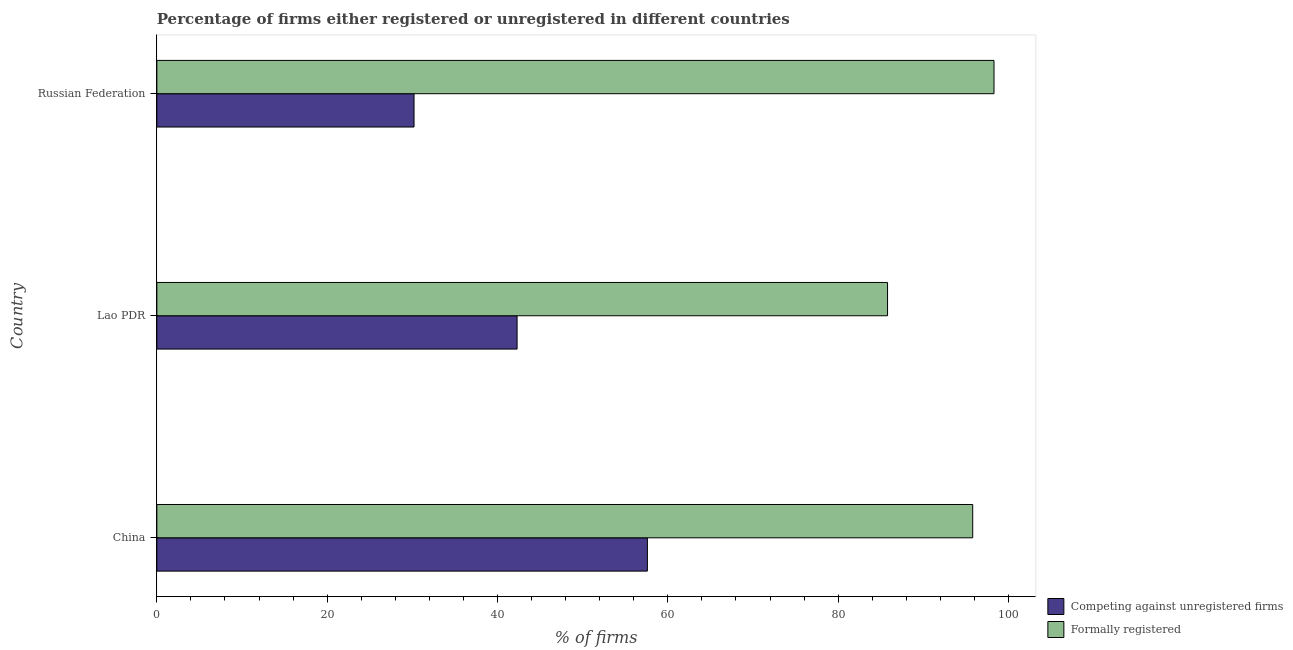How many groups of bars are there?
Your answer should be very brief. 3. Are the number of bars on each tick of the Y-axis equal?
Make the answer very short. Yes. How many bars are there on the 2nd tick from the bottom?
Provide a short and direct response. 2. What is the label of the 1st group of bars from the top?
Make the answer very short. Russian Federation. In how many cases, is the number of bars for a given country not equal to the number of legend labels?
Ensure brevity in your answer.  0. What is the percentage of formally registered firms in Lao PDR?
Your answer should be very brief. 85.8. Across all countries, what is the maximum percentage of registered firms?
Offer a terse response. 57.6. Across all countries, what is the minimum percentage of registered firms?
Your answer should be very brief. 30.2. In which country was the percentage of registered firms maximum?
Your response must be concise. China. In which country was the percentage of registered firms minimum?
Your response must be concise. Russian Federation. What is the total percentage of formally registered firms in the graph?
Offer a terse response. 279.9. What is the difference between the percentage of registered firms in China and the percentage of formally registered firms in Lao PDR?
Your response must be concise. -28.2. What is the average percentage of formally registered firms per country?
Give a very brief answer. 93.3. What is the difference between the percentage of formally registered firms and percentage of registered firms in China?
Your answer should be very brief. 38.2. What is the ratio of the percentage of registered firms in Lao PDR to that in Russian Federation?
Keep it short and to the point. 1.4. Is the percentage of registered firms in Lao PDR less than that in Russian Federation?
Your response must be concise. No. Is the difference between the percentage of formally registered firms in China and Russian Federation greater than the difference between the percentage of registered firms in China and Russian Federation?
Keep it short and to the point. No. What is the difference between the highest and the lowest percentage of registered firms?
Your answer should be very brief. 27.4. What does the 1st bar from the top in China represents?
Your answer should be very brief. Formally registered. What does the 2nd bar from the bottom in Russian Federation represents?
Make the answer very short. Formally registered. How many bars are there?
Your response must be concise. 6. How many countries are there in the graph?
Offer a very short reply. 3. Does the graph contain any zero values?
Your response must be concise. No. Does the graph contain grids?
Offer a terse response. No. Where does the legend appear in the graph?
Provide a succinct answer. Bottom right. How are the legend labels stacked?
Offer a terse response. Vertical. What is the title of the graph?
Make the answer very short. Percentage of firms either registered or unregistered in different countries. Does "Tetanus" appear as one of the legend labels in the graph?
Your response must be concise. No. What is the label or title of the X-axis?
Your answer should be compact. % of firms. What is the % of firms in Competing against unregistered firms in China?
Offer a very short reply. 57.6. What is the % of firms in Formally registered in China?
Provide a short and direct response. 95.8. What is the % of firms of Competing against unregistered firms in Lao PDR?
Your answer should be very brief. 42.3. What is the % of firms in Formally registered in Lao PDR?
Keep it short and to the point. 85.8. What is the % of firms of Competing against unregistered firms in Russian Federation?
Make the answer very short. 30.2. What is the % of firms of Formally registered in Russian Federation?
Your answer should be compact. 98.3. Across all countries, what is the maximum % of firms in Competing against unregistered firms?
Make the answer very short. 57.6. Across all countries, what is the maximum % of firms of Formally registered?
Your answer should be very brief. 98.3. Across all countries, what is the minimum % of firms of Competing against unregistered firms?
Provide a succinct answer. 30.2. Across all countries, what is the minimum % of firms of Formally registered?
Your answer should be compact. 85.8. What is the total % of firms of Competing against unregistered firms in the graph?
Ensure brevity in your answer.  130.1. What is the total % of firms in Formally registered in the graph?
Provide a short and direct response. 279.9. What is the difference between the % of firms in Formally registered in China and that in Lao PDR?
Your answer should be compact. 10. What is the difference between the % of firms of Competing against unregistered firms in China and that in Russian Federation?
Provide a short and direct response. 27.4. What is the difference between the % of firms of Formally registered in China and that in Russian Federation?
Provide a succinct answer. -2.5. What is the difference between the % of firms of Competing against unregistered firms in Lao PDR and that in Russian Federation?
Provide a succinct answer. 12.1. What is the difference between the % of firms of Competing against unregistered firms in China and the % of firms of Formally registered in Lao PDR?
Offer a very short reply. -28.2. What is the difference between the % of firms of Competing against unregistered firms in China and the % of firms of Formally registered in Russian Federation?
Your answer should be compact. -40.7. What is the difference between the % of firms in Competing against unregistered firms in Lao PDR and the % of firms in Formally registered in Russian Federation?
Ensure brevity in your answer.  -56. What is the average % of firms of Competing against unregistered firms per country?
Your answer should be compact. 43.37. What is the average % of firms of Formally registered per country?
Offer a very short reply. 93.3. What is the difference between the % of firms in Competing against unregistered firms and % of firms in Formally registered in China?
Ensure brevity in your answer.  -38.2. What is the difference between the % of firms in Competing against unregistered firms and % of firms in Formally registered in Lao PDR?
Provide a short and direct response. -43.5. What is the difference between the % of firms of Competing against unregistered firms and % of firms of Formally registered in Russian Federation?
Give a very brief answer. -68.1. What is the ratio of the % of firms in Competing against unregistered firms in China to that in Lao PDR?
Your answer should be very brief. 1.36. What is the ratio of the % of firms in Formally registered in China to that in Lao PDR?
Keep it short and to the point. 1.12. What is the ratio of the % of firms in Competing against unregistered firms in China to that in Russian Federation?
Your response must be concise. 1.91. What is the ratio of the % of firms of Formally registered in China to that in Russian Federation?
Your response must be concise. 0.97. What is the ratio of the % of firms of Competing against unregistered firms in Lao PDR to that in Russian Federation?
Provide a short and direct response. 1.4. What is the ratio of the % of firms in Formally registered in Lao PDR to that in Russian Federation?
Keep it short and to the point. 0.87. What is the difference between the highest and the second highest % of firms in Competing against unregistered firms?
Ensure brevity in your answer.  15.3. What is the difference between the highest and the lowest % of firms in Competing against unregistered firms?
Provide a succinct answer. 27.4. What is the difference between the highest and the lowest % of firms of Formally registered?
Keep it short and to the point. 12.5. 